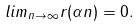<formula> <loc_0><loc_0><loc_500><loc_500>l i m _ { n \rightarrow \infty } r ( \alpha n ) = 0 .</formula> 